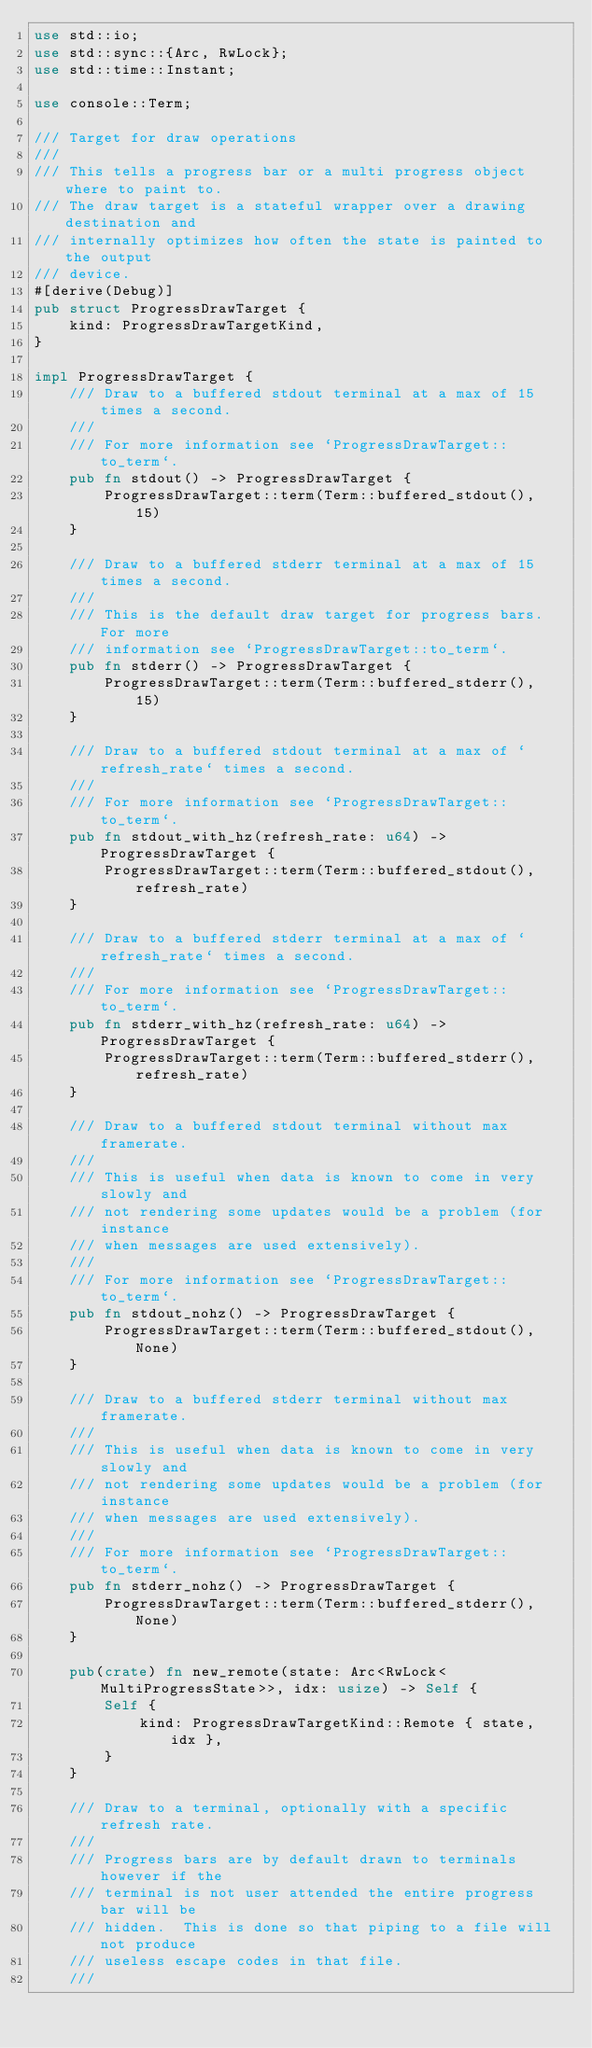<code> <loc_0><loc_0><loc_500><loc_500><_Rust_>use std::io;
use std::sync::{Arc, RwLock};
use std::time::Instant;

use console::Term;

/// Target for draw operations
///
/// This tells a progress bar or a multi progress object where to paint to.
/// The draw target is a stateful wrapper over a drawing destination and
/// internally optimizes how often the state is painted to the output
/// device.
#[derive(Debug)]
pub struct ProgressDrawTarget {
    kind: ProgressDrawTargetKind,
}

impl ProgressDrawTarget {
    /// Draw to a buffered stdout terminal at a max of 15 times a second.
    ///
    /// For more information see `ProgressDrawTarget::to_term`.
    pub fn stdout() -> ProgressDrawTarget {
        ProgressDrawTarget::term(Term::buffered_stdout(), 15)
    }

    /// Draw to a buffered stderr terminal at a max of 15 times a second.
    ///
    /// This is the default draw target for progress bars.  For more
    /// information see `ProgressDrawTarget::to_term`.
    pub fn stderr() -> ProgressDrawTarget {
        ProgressDrawTarget::term(Term::buffered_stderr(), 15)
    }

    /// Draw to a buffered stdout terminal at a max of `refresh_rate` times a second.
    ///
    /// For more information see `ProgressDrawTarget::to_term`.
    pub fn stdout_with_hz(refresh_rate: u64) -> ProgressDrawTarget {
        ProgressDrawTarget::term(Term::buffered_stdout(), refresh_rate)
    }

    /// Draw to a buffered stderr terminal at a max of `refresh_rate` times a second.
    ///
    /// For more information see `ProgressDrawTarget::to_term`.
    pub fn stderr_with_hz(refresh_rate: u64) -> ProgressDrawTarget {
        ProgressDrawTarget::term(Term::buffered_stderr(), refresh_rate)
    }

    /// Draw to a buffered stdout terminal without max framerate.
    ///
    /// This is useful when data is known to come in very slowly and
    /// not rendering some updates would be a problem (for instance
    /// when messages are used extensively).
    ///
    /// For more information see `ProgressDrawTarget::to_term`.
    pub fn stdout_nohz() -> ProgressDrawTarget {
        ProgressDrawTarget::term(Term::buffered_stdout(), None)
    }

    /// Draw to a buffered stderr terminal without max framerate.
    ///
    /// This is useful when data is known to come in very slowly and
    /// not rendering some updates would be a problem (for instance
    /// when messages are used extensively).
    ///
    /// For more information see `ProgressDrawTarget::to_term`.
    pub fn stderr_nohz() -> ProgressDrawTarget {
        ProgressDrawTarget::term(Term::buffered_stderr(), None)
    }

    pub(crate) fn new_remote(state: Arc<RwLock<MultiProgressState>>, idx: usize) -> Self {
        Self {
            kind: ProgressDrawTargetKind::Remote { state, idx },
        }
    }

    /// Draw to a terminal, optionally with a specific refresh rate.
    ///
    /// Progress bars are by default drawn to terminals however if the
    /// terminal is not user attended the entire progress bar will be
    /// hidden.  This is done so that piping to a file will not produce
    /// useless escape codes in that file.
    ///</code> 